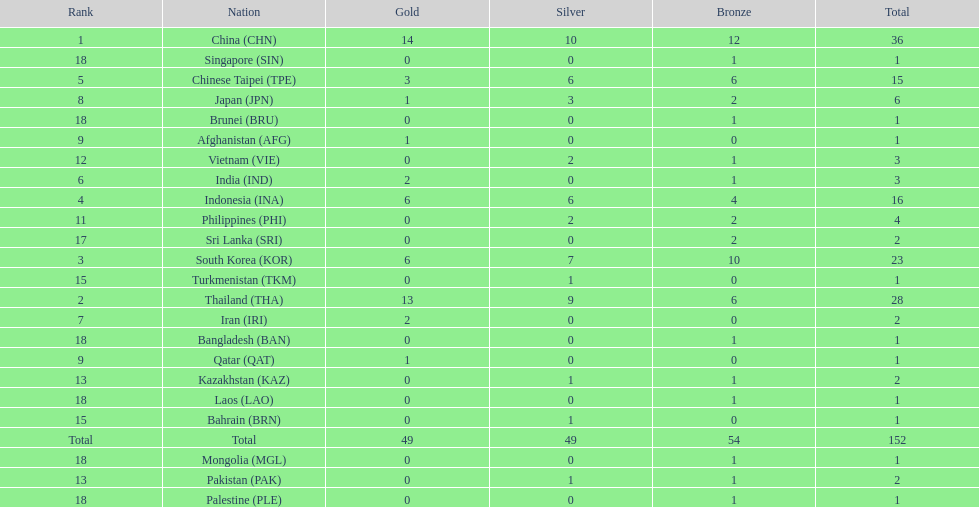How many nations won no silver medals at all? 11. 